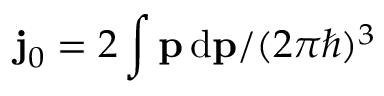<formula> <loc_0><loc_0><loc_500><loc_500>{ j _ { 0 } } = 2 \int p \, d p / ( 2 \pi \hbar { ) } ^ { 3 }</formula> 